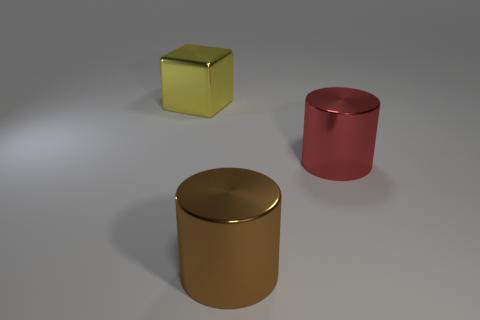Add 2 brown metallic cylinders. How many objects exist? 5 Subtract all brown cylinders. How many cylinders are left? 1 Add 2 big brown things. How many big brown things exist? 3 Subtract 0 gray cubes. How many objects are left? 3 Subtract all cylinders. How many objects are left? 1 Subtract all red objects. Subtract all tiny blue rubber things. How many objects are left? 2 Add 1 brown cylinders. How many brown cylinders are left? 2 